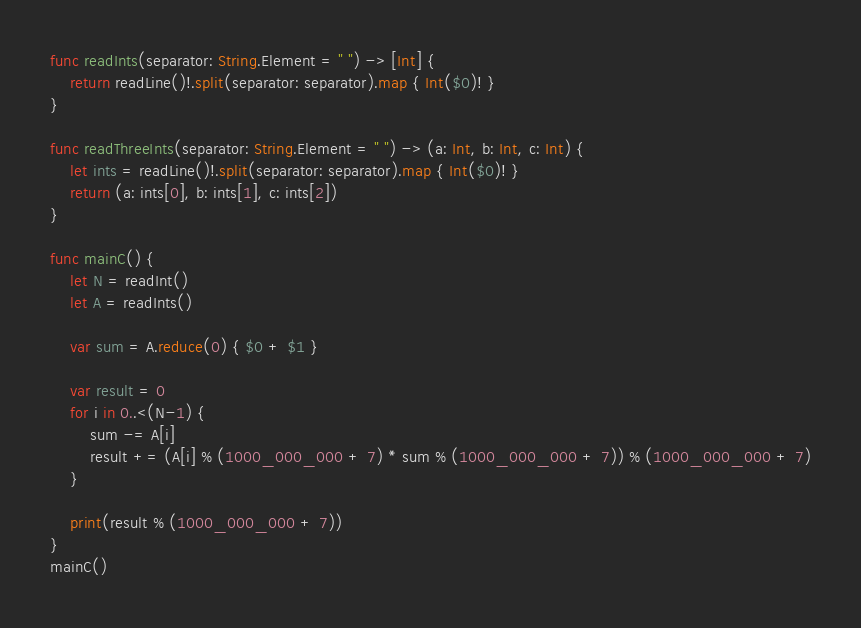<code> <loc_0><loc_0><loc_500><loc_500><_Swift_>func readInts(separator: String.Element = " ") -> [Int] {
    return readLine()!.split(separator: separator).map { Int($0)! }
}

func readThreeInts(separator: String.Element = " ") -> (a: Int, b: Int, c: Int) {
    let ints = readLine()!.split(separator: separator).map { Int($0)! }
    return (a: ints[0], b: ints[1], c: ints[2])
}

func mainC() {
    let N = readInt()
    let A = readInts()

    var sum = A.reduce(0) { $0 + $1 }

    var result = 0
    for i in 0..<(N-1) {
        sum -= A[i]
        result += (A[i] % (1000_000_000 + 7) * sum % (1000_000_000 + 7)) % (1000_000_000 + 7)
    }

    print(result % (1000_000_000 + 7))
}
mainC()</code> 